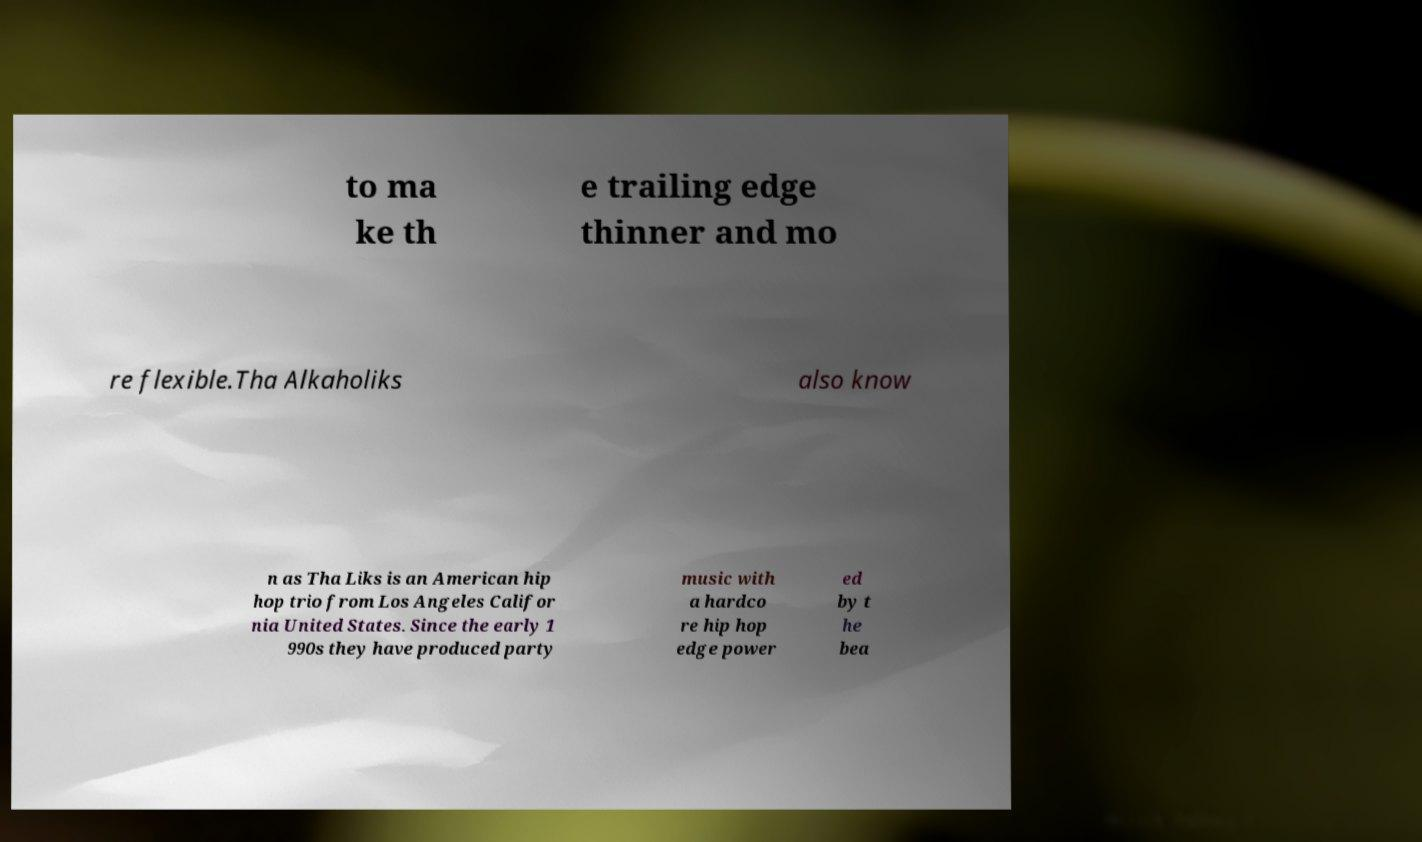Can you accurately transcribe the text from the provided image for me? to ma ke th e trailing edge thinner and mo re flexible.Tha Alkaholiks also know n as Tha Liks is an American hip hop trio from Los Angeles Califor nia United States. Since the early 1 990s they have produced party music with a hardco re hip hop edge power ed by t he bea 